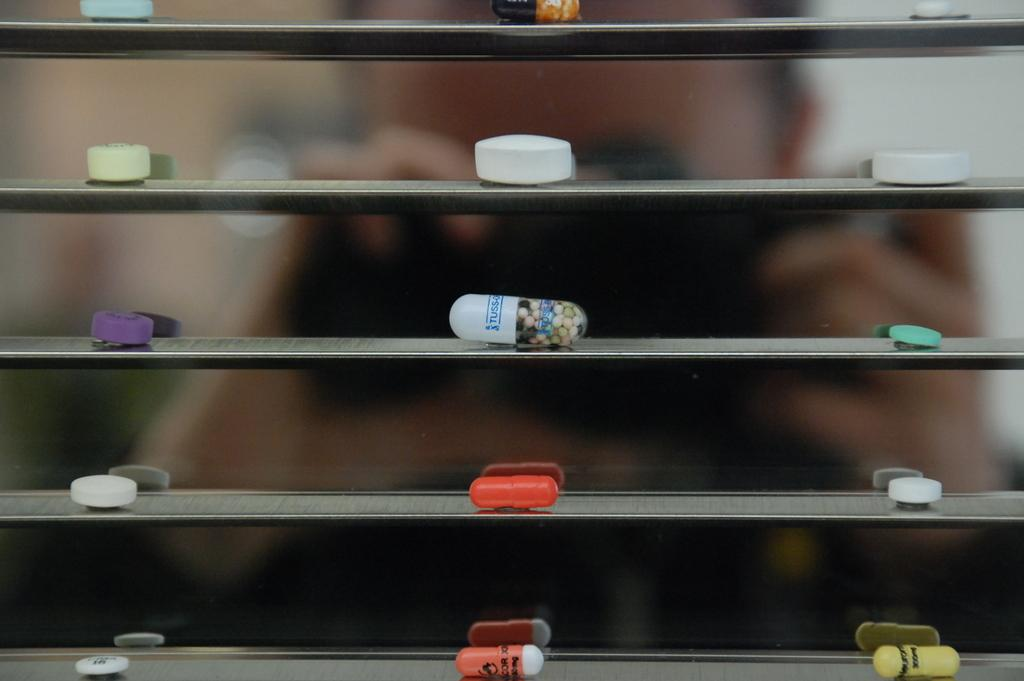What is the general appearance of the background in the image? The background of the image is blurred. Can you identify any subjects in the foreground of the image? Yes, there is a person in the image. What type of objects can be seen in the middle of the image? There are capsules and tablets on display in the middle of the image. What color is the pin on the person's shirt in the image? There is no pin or shirt mentioned in the image, as it only describes a person, a blurred background, and capsules and tablets in the middle. 